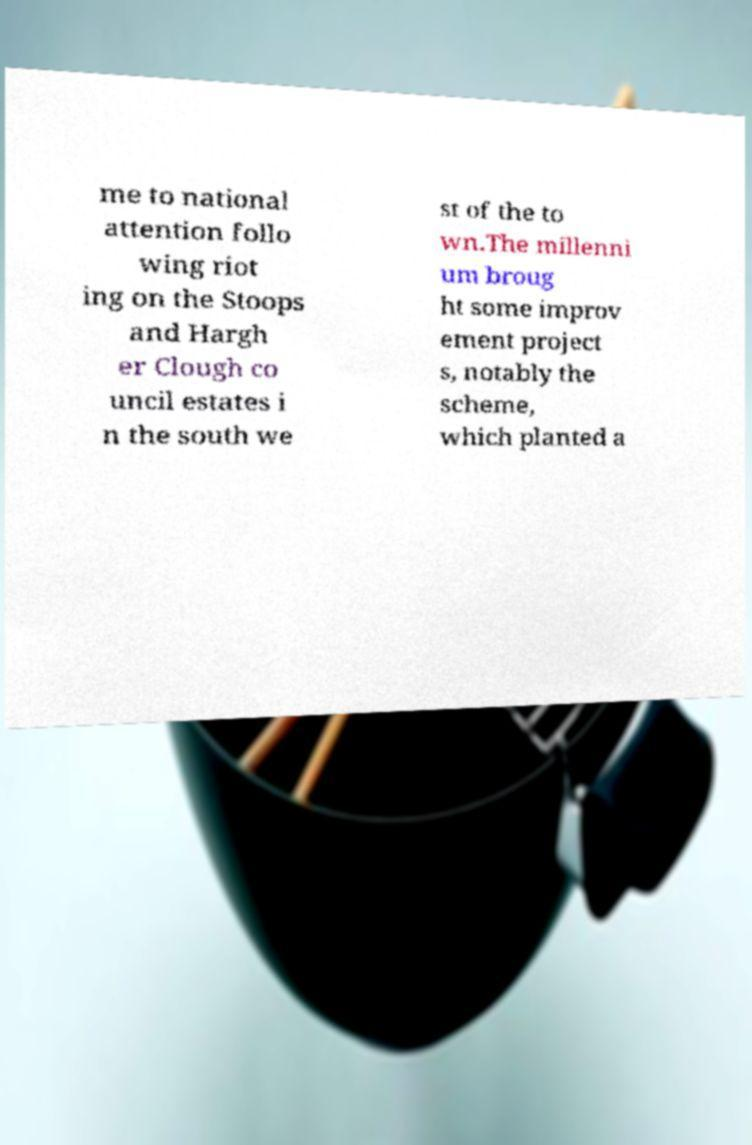Can you read and provide the text displayed in the image?This photo seems to have some interesting text. Can you extract and type it out for me? me to national attention follo wing riot ing on the Stoops and Hargh er Clough co uncil estates i n the south we st of the to wn.The millenni um broug ht some improv ement project s, notably the scheme, which planted a 